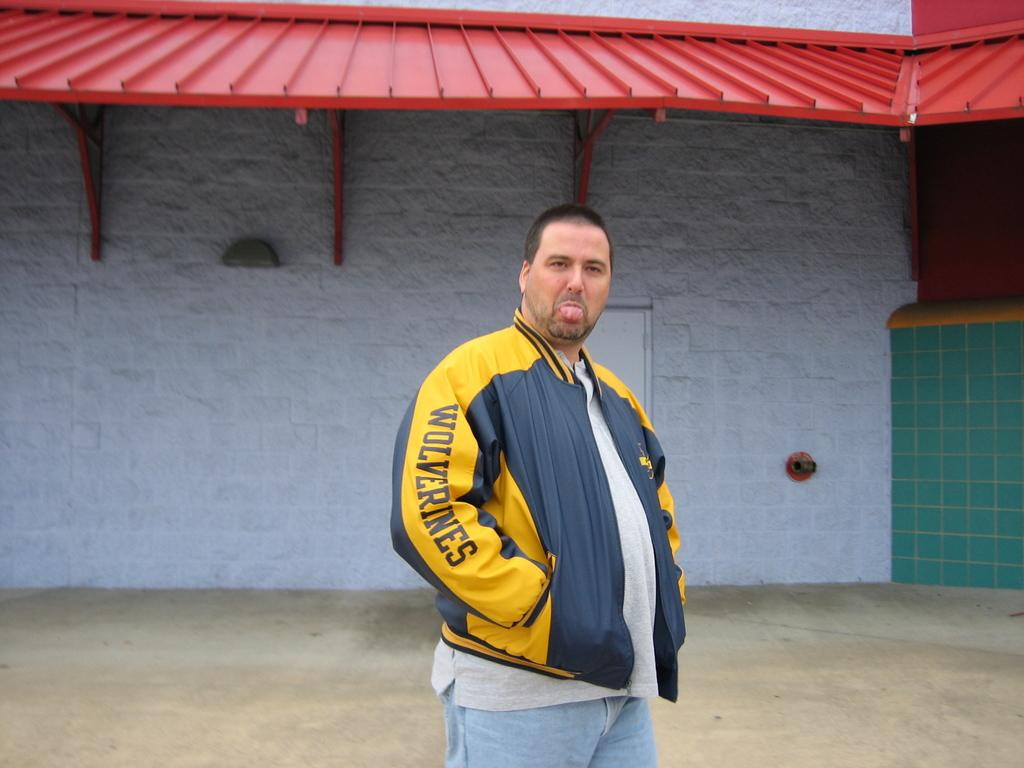<image>
Provide a brief description of the given image. A man is wearing a jacket that says Wolverines on the sleeve. 